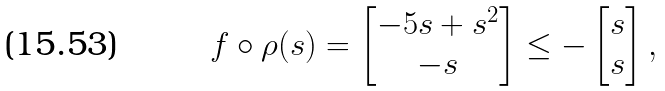Convert formula to latex. <formula><loc_0><loc_0><loc_500><loc_500>f \circ \rho ( s ) = \begin{bmatrix} - 5 s + s ^ { 2 } \\ - s \end{bmatrix} \leq - \begin{bmatrix} s \\ s \end{bmatrix} ,</formula> 